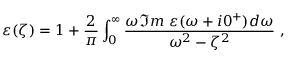<formula> <loc_0><loc_0><loc_500><loc_500>\varepsilon ( \zeta ) = 1 + { \frac { 2 } { \pi } } \int _ { 0 } ^ { \infty } { \frac { \omega \Im m \ \varepsilon ( \omega + i 0 ^ { + } ) d \omega } { \omega ^ { 2 } - \zeta ^ { 2 } } } \ ,</formula> 